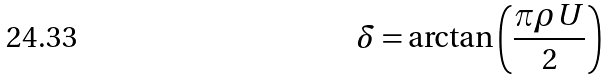<formula> <loc_0><loc_0><loc_500><loc_500>\delta = \arctan \left ( \frac { \pi \rho U } { 2 } \right )</formula> 